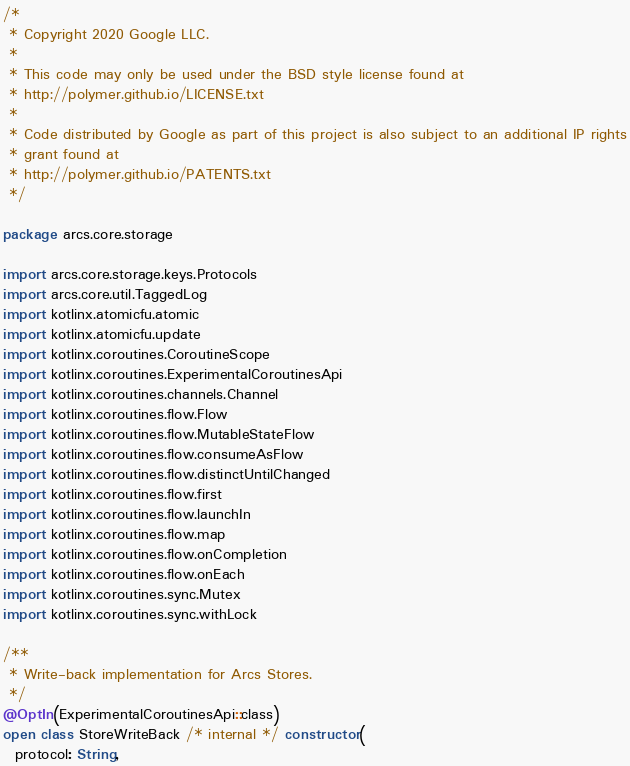Convert code to text. <code><loc_0><loc_0><loc_500><loc_500><_Kotlin_>/*
 * Copyright 2020 Google LLC.
 *
 * This code may only be used under the BSD style license found at
 * http://polymer.github.io/LICENSE.txt
 *
 * Code distributed by Google as part of this project is also subject to an additional IP rights
 * grant found at
 * http://polymer.github.io/PATENTS.txt
 */

package arcs.core.storage

import arcs.core.storage.keys.Protocols
import arcs.core.util.TaggedLog
import kotlinx.atomicfu.atomic
import kotlinx.atomicfu.update
import kotlinx.coroutines.CoroutineScope
import kotlinx.coroutines.ExperimentalCoroutinesApi
import kotlinx.coroutines.channels.Channel
import kotlinx.coroutines.flow.Flow
import kotlinx.coroutines.flow.MutableStateFlow
import kotlinx.coroutines.flow.consumeAsFlow
import kotlinx.coroutines.flow.distinctUntilChanged
import kotlinx.coroutines.flow.first
import kotlinx.coroutines.flow.launchIn
import kotlinx.coroutines.flow.map
import kotlinx.coroutines.flow.onCompletion
import kotlinx.coroutines.flow.onEach
import kotlinx.coroutines.sync.Mutex
import kotlinx.coroutines.sync.withLock

/**
 * Write-back implementation for Arcs Stores.
 */
@OptIn(ExperimentalCoroutinesApi::class)
open class StoreWriteBack /* internal */ constructor(
  protocol: String,</code> 